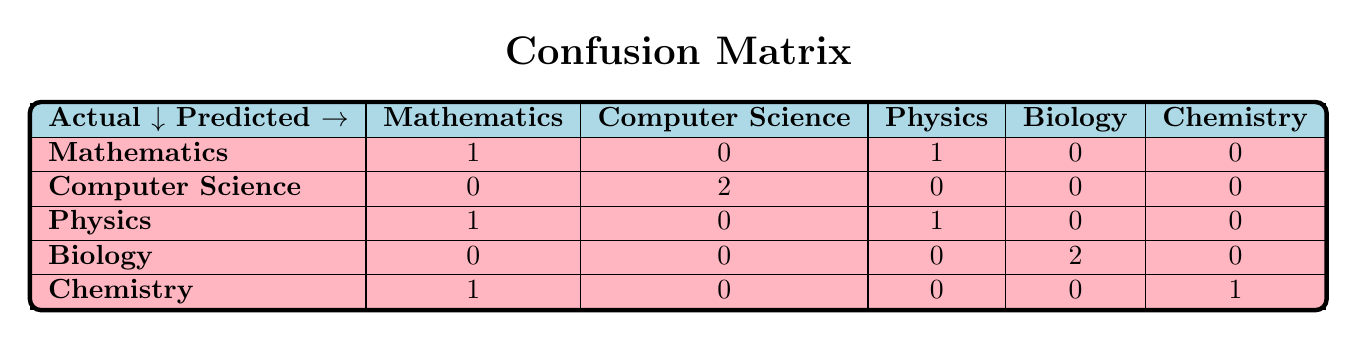What is the number of times Mathematics was correctly predicted? In the confusion matrix, we look at the row for Mathematics. The correct predictions are located in the first column, which shows a count of '1'.
Answer: 1 How many courses were never predicted incorrectly? To find courses that were never predicted incorrectly, we need to check each row for a count of '0' in the corresponding predicted categories. Listing the rows: Mathematics has one incorrect prediction, Computer Science has zero incorrect predictions, Physics has one incorrect prediction, Biology has zero incorrect predictions, and Chemistry has one incorrect prediction. The courses that were never predicted incorrectly are Computer Science and Biology.
Answer: 2 What is the total number of times Biology was predicted correctly? Looking at the row for Biology in the confusion matrix, the correct predictions can be found in its corresponding column. The count is '2' in the Biology row indicating the number of times Biology was accurately predicted.
Answer: 2 What percentage of predicted Mathematics are actually Computer Science? In the confusion matrix, the row for Mathematics has a predicted category of Computer Science showing '0'. The total predictions for Mathematics is '2' (1 correct and 1 incorrect). As there are '0' predicted as Computer Science, the percentage calculation is (0/2) * 100 = 0%.
Answer: 0% Was Chemistry more accurately predicted than Physics? In the confusion matrix, we look at the correct predictions for both Chemistry and Physics. Chemistry has 1 correct prediction while Physics has 1 correct prediction as well. Since both have the same number of accurate predictions (1), we can conclude that they are equally accurate.
Answer: No 